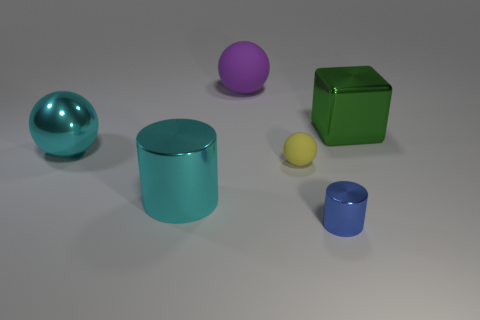What material is the sphere that is the same color as the large cylinder?
Keep it short and to the point. Metal. There is a thing that is behind the green cube; is it the same shape as the small metallic object?
Your answer should be very brief. No. Are there fewer small rubber spheres on the right side of the blue cylinder than green cubes in front of the green block?
Make the answer very short. No. What is the material of the large thing to the right of the tiny blue metallic cylinder?
Provide a succinct answer. Metal. There is a cylinder that is the same color as the big metal sphere; what is its size?
Provide a succinct answer. Large. Are there any brown cylinders of the same size as the metallic sphere?
Keep it short and to the point. No. Is the shape of the big green metallic object the same as the large cyan metal thing that is in front of the metal ball?
Provide a succinct answer. No. There is a yellow object in front of the cyan metallic ball; is it the same size as the metal thing in front of the cyan shiny cylinder?
Offer a terse response. Yes. How many other things are the same shape as the purple thing?
Provide a short and direct response. 2. There is a big thing that is behind the big object that is to the right of the small blue metallic cylinder; what is it made of?
Your answer should be compact. Rubber. 